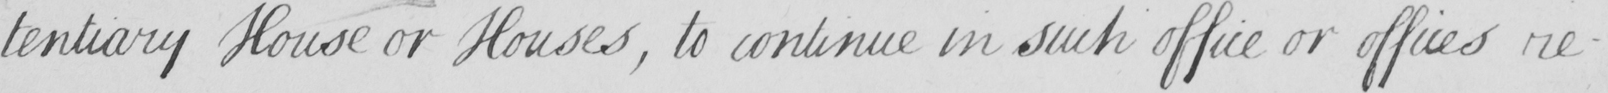Can you read and transcribe this handwriting? -tentiary House or Houses , to continue in such office or offices re- 